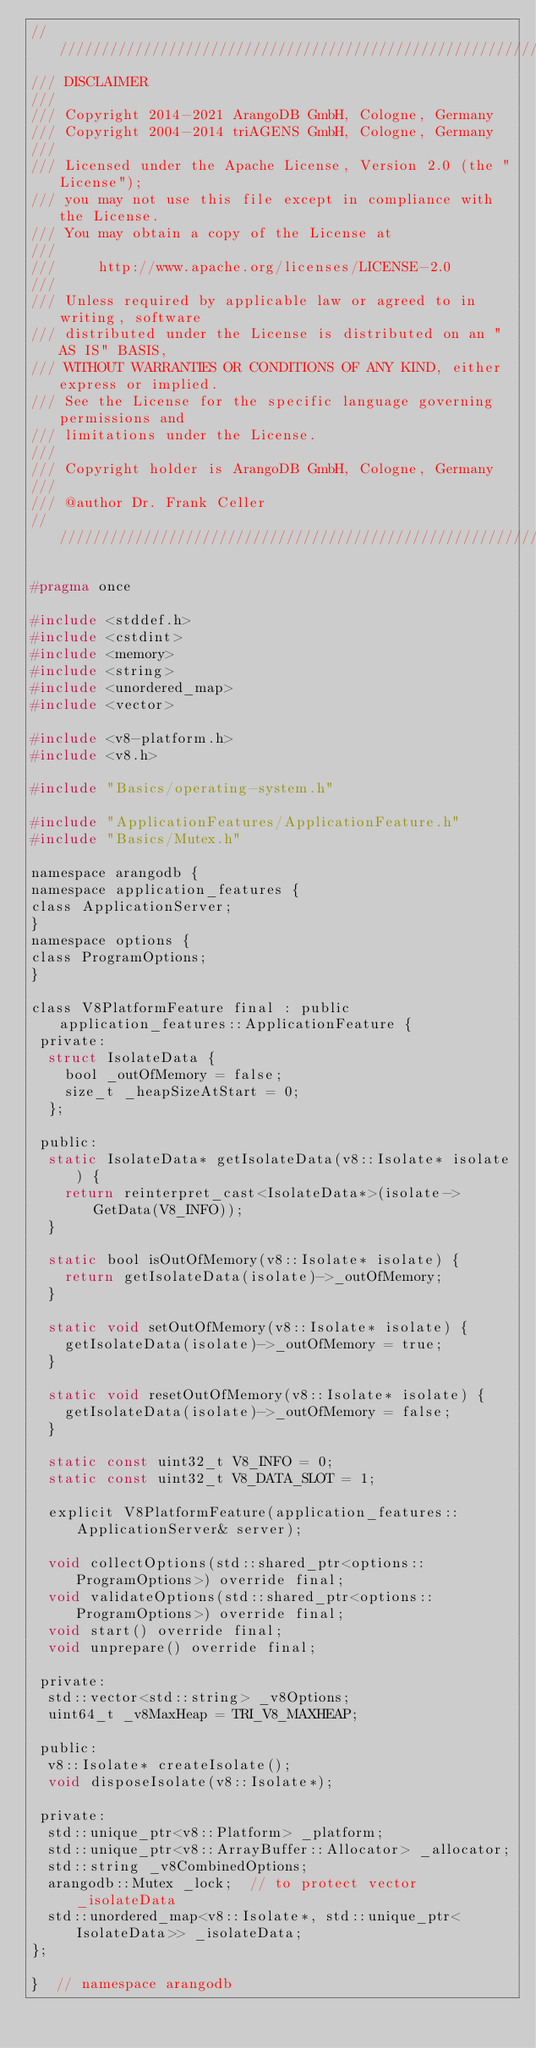<code> <loc_0><loc_0><loc_500><loc_500><_C_>////////////////////////////////////////////////////////////////////////////////
/// DISCLAIMER
///
/// Copyright 2014-2021 ArangoDB GmbH, Cologne, Germany
/// Copyright 2004-2014 triAGENS GmbH, Cologne, Germany
///
/// Licensed under the Apache License, Version 2.0 (the "License");
/// you may not use this file except in compliance with the License.
/// You may obtain a copy of the License at
///
///     http://www.apache.org/licenses/LICENSE-2.0
///
/// Unless required by applicable law or agreed to in writing, software
/// distributed under the License is distributed on an "AS IS" BASIS,
/// WITHOUT WARRANTIES OR CONDITIONS OF ANY KIND, either express or implied.
/// See the License for the specific language governing permissions and
/// limitations under the License.
///
/// Copyright holder is ArangoDB GmbH, Cologne, Germany
///
/// @author Dr. Frank Celler
////////////////////////////////////////////////////////////////////////////////

#pragma once

#include <stddef.h>
#include <cstdint>
#include <memory>
#include <string>
#include <unordered_map>
#include <vector>

#include <v8-platform.h>
#include <v8.h>

#include "Basics/operating-system.h"

#include "ApplicationFeatures/ApplicationFeature.h"
#include "Basics/Mutex.h"

namespace arangodb {
namespace application_features {
class ApplicationServer;
}
namespace options {
class ProgramOptions;
}

class V8PlatformFeature final : public application_features::ApplicationFeature {
 private:
  struct IsolateData {
    bool _outOfMemory = false;
    size_t _heapSizeAtStart = 0;
  };

 public:
  static IsolateData* getIsolateData(v8::Isolate* isolate) {
    return reinterpret_cast<IsolateData*>(isolate->GetData(V8_INFO));
  }

  static bool isOutOfMemory(v8::Isolate* isolate) {
    return getIsolateData(isolate)->_outOfMemory;
  }

  static void setOutOfMemory(v8::Isolate* isolate) {
    getIsolateData(isolate)->_outOfMemory = true;
  }

  static void resetOutOfMemory(v8::Isolate* isolate) {
    getIsolateData(isolate)->_outOfMemory = false;
  }

  static const uint32_t V8_INFO = 0;
  static const uint32_t V8_DATA_SLOT = 1;

  explicit V8PlatformFeature(application_features::ApplicationServer& server);

  void collectOptions(std::shared_ptr<options::ProgramOptions>) override final;
  void validateOptions(std::shared_ptr<options::ProgramOptions>) override final;
  void start() override final;
  void unprepare() override final;

 private:
  std::vector<std::string> _v8Options;
  uint64_t _v8MaxHeap = TRI_V8_MAXHEAP;

 public:
  v8::Isolate* createIsolate();
  void disposeIsolate(v8::Isolate*);

 private:
  std::unique_ptr<v8::Platform> _platform;
  std::unique_ptr<v8::ArrayBuffer::Allocator> _allocator;
  std::string _v8CombinedOptions;
  arangodb::Mutex _lock;  // to protect vector _isolateData
  std::unordered_map<v8::Isolate*, std::unique_ptr<IsolateData>> _isolateData;
};

}  // namespace arangodb

</code> 